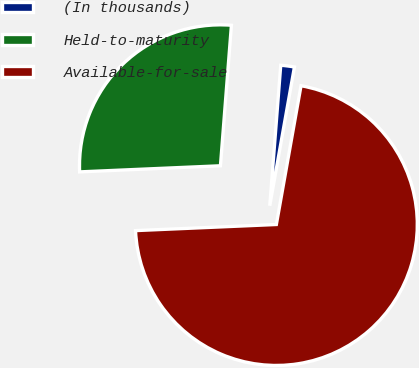Convert chart to OTSL. <chart><loc_0><loc_0><loc_500><loc_500><pie_chart><fcel>(In thousands)<fcel>Held-to-maturity<fcel>Available-for-sale<nl><fcel>1.56%<fcel>26.93%<fcel>71.51%<nl></chart> 